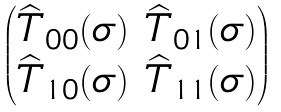<formula> <loc_0><loc_0><loc_500><loc_500>\begin{pmatrix} \widehat { T } _ { 0 0 } ( \sigma ) & \widehat { T } _ { 0 1 } ( \sigma ) \\ \widehat { T } _ { 1 0 } ( \sigma ) & \widehat { T } _ { 1 1 } ( \sigma ) \\ \end{pmatrix}</formula> 